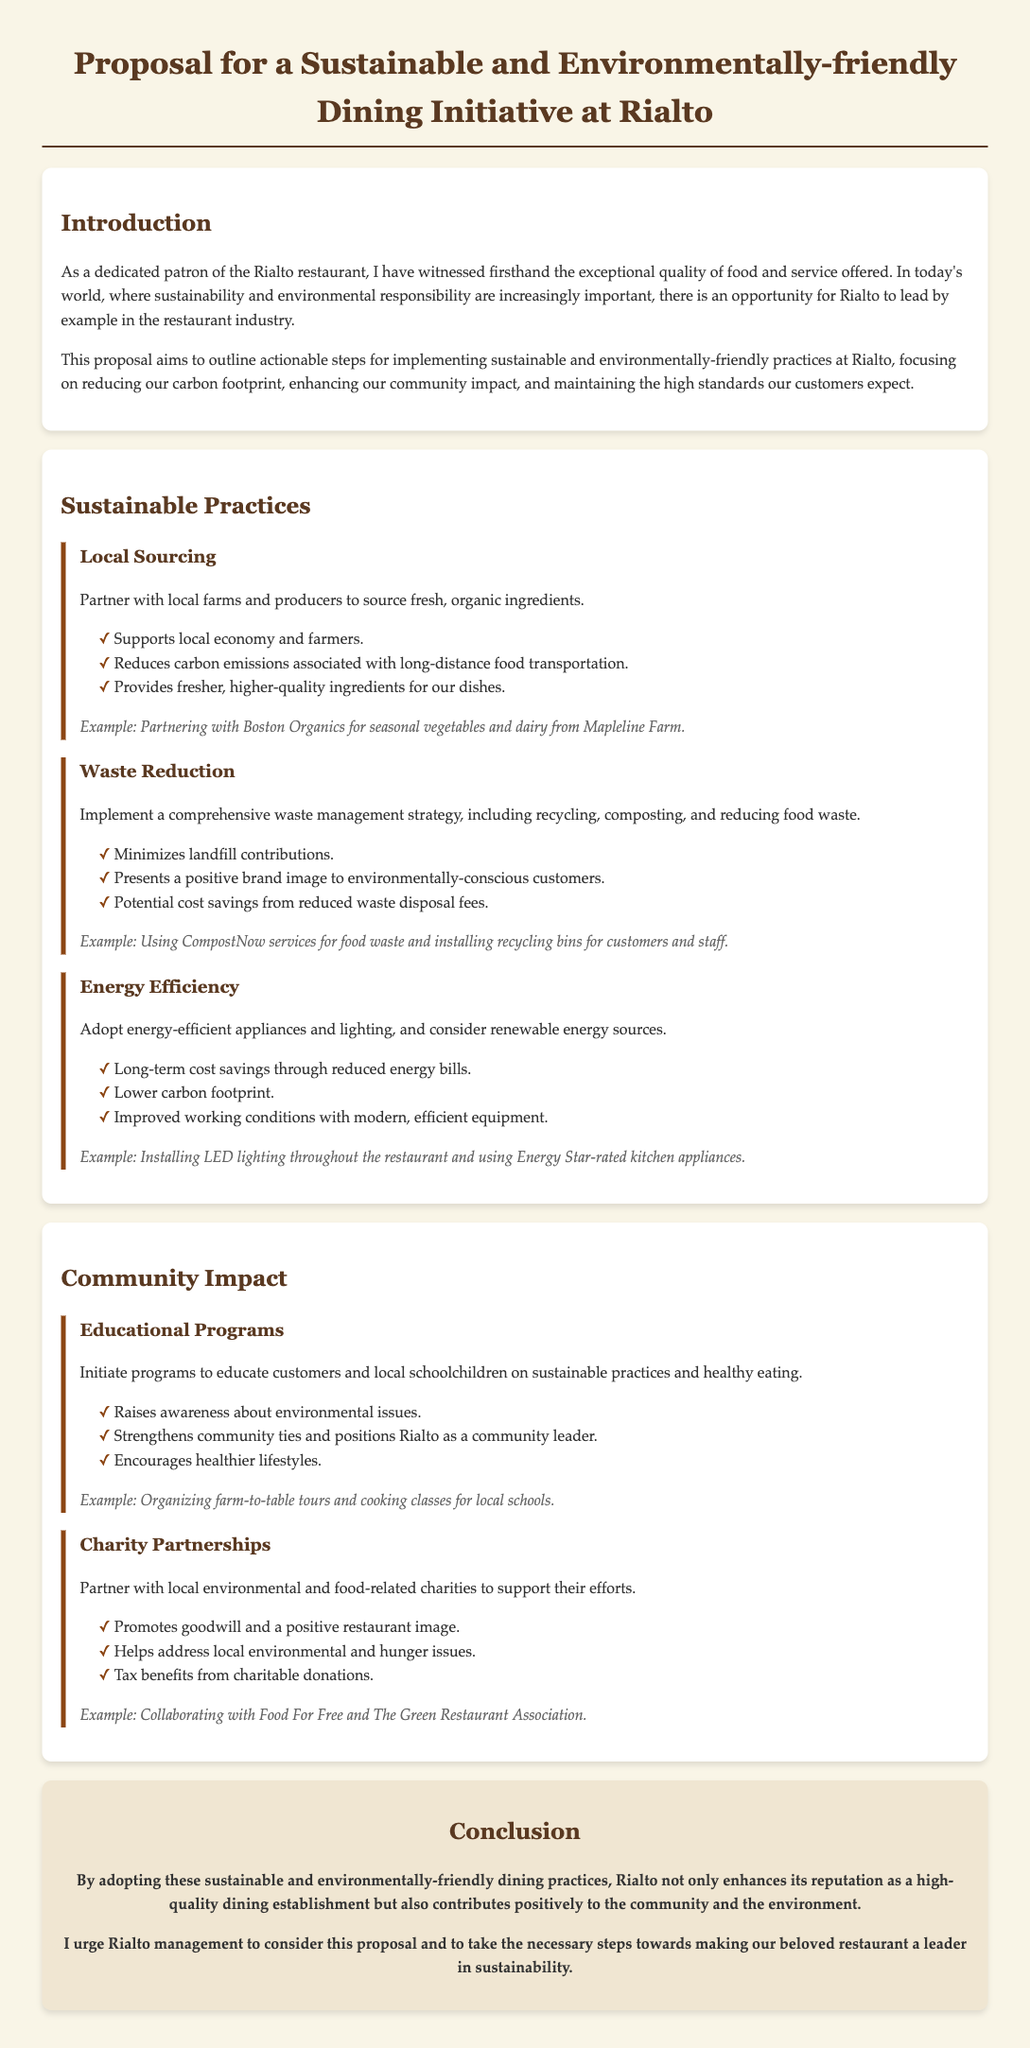What is the title of the proposal? The title of the proposal is stated at the top of the document.
Answer: Proposal for a Sustainable and Environmentally-friendly Dining Initiative at Rialto How many sustainable practices are mentioned in the document? The document lists three specific practices under sustainable practices.
Answer: Three What is one example of local sourcing mentioned? The document provides an example under the Local Sourcing section.
Answer: Partnering with Boston Organics What does the Waste Reduction strategy aim to minimize? The document describes the Waste Reduction strategy's goal.
Answer: Landfill contributions What is a potential benefit of energy-efficient appliances mentioned? The document outlines several benefits under Energy Efficiency practices.
Answer: Long-term cost savings What type of programs are suggested for educational outreach? The document suggests specific types of programs under the Community Impact section.
Answer: Educational programs Which local charity is mentioned for partnership? The document lists specific charities under Charity Partnerships.
Answer: Food For Free How does the proposal describe Rialto's potential community role? The proposal discusses Rialto's positioning within the community.
Answer: Community leader What is the conclusion's call to action for Rialto management? The proposal's conclusion emphasizes a specific action.
Answer: Consider this proposal 